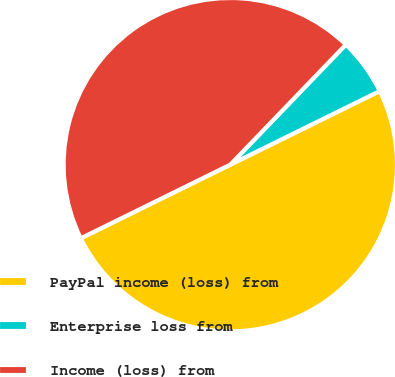Convert chart to OTSL. <chart><loc_0><loc_0><loc_500><loc_500><pie_chart><fcel>PayPal income (loss) from<fcel>Enterprise loss from<fcel>Income (loss) from<nl><fcel>50.0%<fcel>5.52%<fcel>44.48%<nl></chart> 